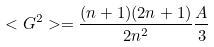<formula> <loc_0><loc_0><loc_500><loc_500>< G ^ { 2 } > = \frac { ( n + 1 ) ( 2 n + 1 ) } { 2 n ^ { 2 } } \frac { A } { 3 }</formula> 